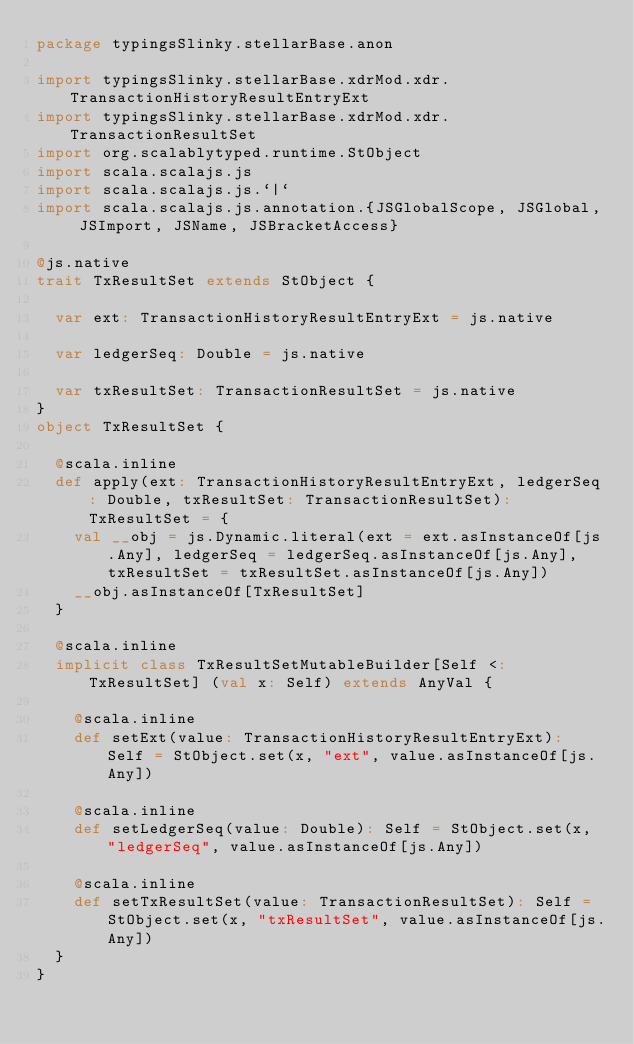Convert code to text. <code><loc_0><loc_0><loc_500><loc_500><_Scala_>package typingsSlinky.stellarBase.anon

import typingsSlinky.stellarBase.xdrMod.xdr.TransactionHistoryResultEntryExt
import typingsSlinky.stellarBase.xdrMod.xdr.TransactionResultSet
import org.scalablytyped.runtime.StObject
import scala.scalajs.js
import scala.scalajs.js.`|`
import scala.scalajs.js.annotation.{JSGlobalScope, JSGlobal, JSImport, JSName, JSBracketAccess}

@js.native
trait TxResultSet extends StObject {
  
  var ext: TransactionHistoryResultEntryExt = js.native
  
  var ledgerSeq: Double = js.native
  
  var txResultSet: TransactionResultSet = js.native
}
object TxResultSet {
  
  @scala.inline
  def apply(ext: TransactionHistoryResultEntryExt, ledgerSeq: Double, txResultSet: TransactionResultSet): TxResultSet = {
    val __obj = js.Dynamic.literal(ext = ext.asInstanceOf[js.Any], ledgerSeq = ledgerSeq.asInstanceOf[js.Any], txResultSet = txResultSet.asInstanceOf[js.Any])
    __obj.asInstanceOf[TxResultSet]
  }
  
  @scala.inline
  implicit class TxResultSetMutableBuilder[Self <: TxResultSet] (val x: Self) extends AnyVal {
    
    @scala.inline
    def setExt(value: TransactionHistoryResultEntryExt): Self = StObject.set(x, "ext", value.asInstanceOf[js.Any])
    
    @scala.inline
    def setLedgerSeq(value: Double): Self = StObject.set(x, "ledgerSeq", value.asInstanceOf[js.Any])
    
    @scala.inline
    def setTxResultSet(value: TransactionResultSet): Self = StObject.set(x, "txResultSet", value.asInstanceOf[js.Any])
  }
}
</code> 